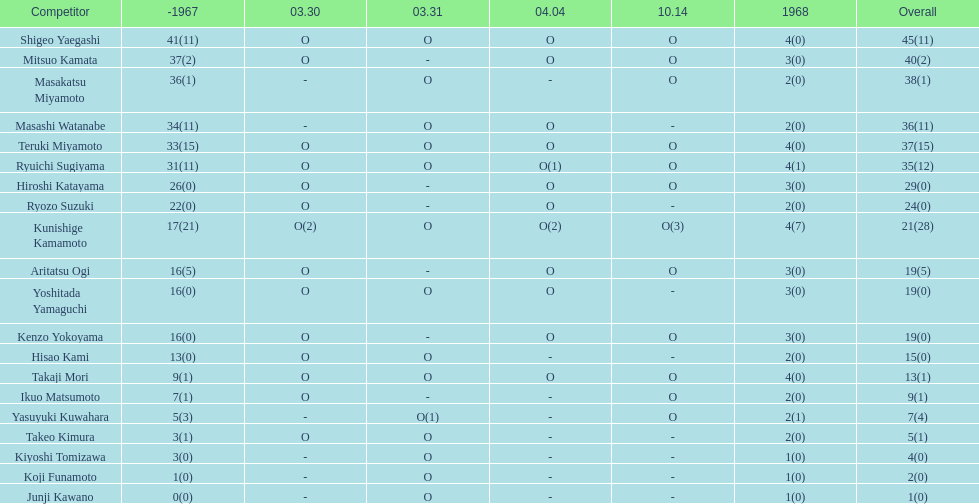What is the complete sum of mitsuo kamata? 40(2). 